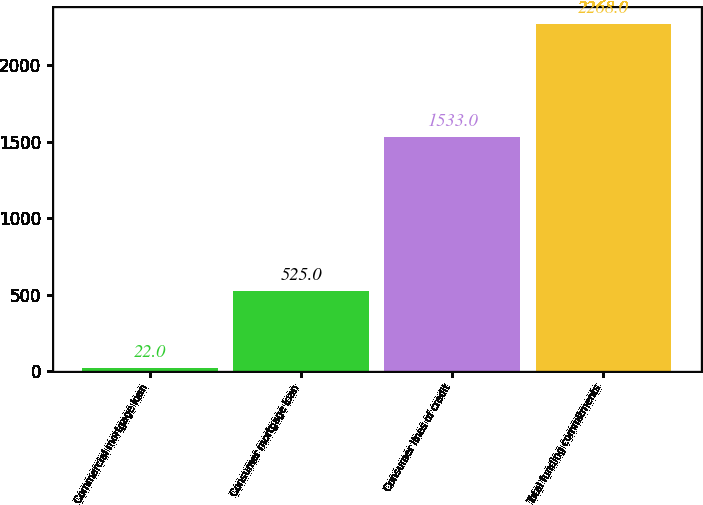<chart> <loc_0><loc_0><loc_500><loc_500><bar_chart><fcel>Commercial mortgage loan<fcel>Consumer mortgage loan<fcel>Consumer lines of credit<fcel>Total funding commitments<nl><fcel>22<fcel>525<fcel>1533<fcel>2268<nl></chart> 